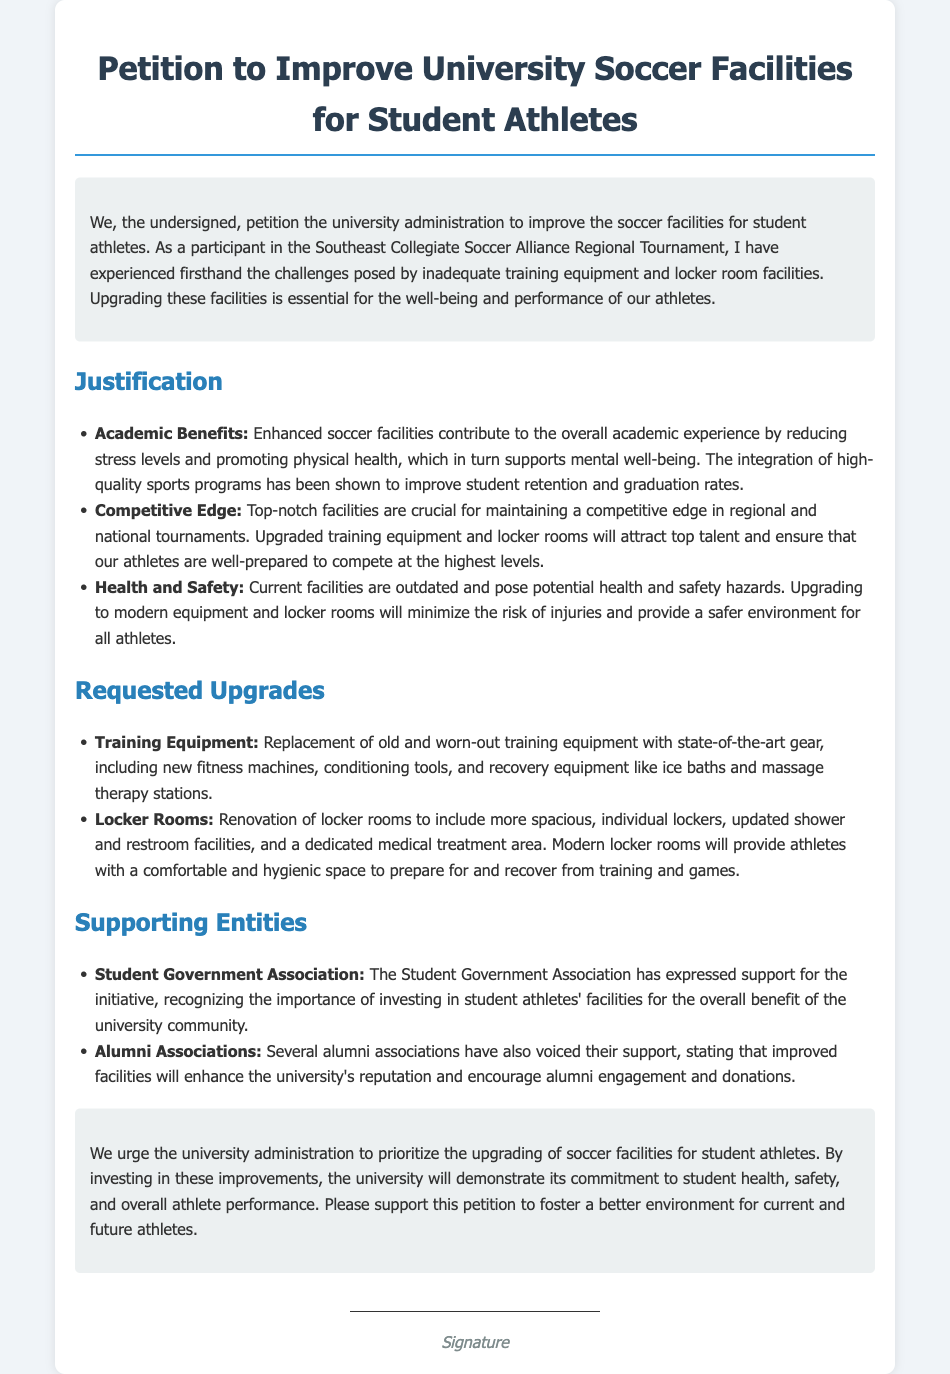What is the title of the petition? The title of the petition is presented at the top of the document.
Answer: Petition to Improve University Soccer Facilities for Student Athletes Who supports the petition besides the student athletes? The document lists organizations that support the petition.
Answer: Student Government Association and Alumni Associations What specific improvements are requested for training equipment? The document outlines upgrades needed, specifically for training equipment.
Answer: Replacement of old and worn-out training equipment Which tournament did the petition mention? The petition references a specific tournament that the author participated in.
Answer: Southeast Collegiate Soccer Alliance Regional Tournament What is one benefit of enhanced soccer facilities mentioned in the justification? The justification section lists various benefits related to improved facilities.
Answer: Reducing stress levels What is included in the requested upgrades for locker rooms? The requested upgrades section details enhancements needed for locker rooms.
Answer: More spacious, individual lockers How are health and safety addressed in the petition? The petition discusses health and safety issues related to current facilities.
Answer: Outdated and pose potential health and safety hazards What is the purpose of the petition? The introductory paragraph clarifies the aim of the petition.
Answer: To improve the soccer facilities for student athletes What type of facility renovations are discussed in the document? The document describes renovations needed for a specific athletic facility.
Answer: Locker rooms 